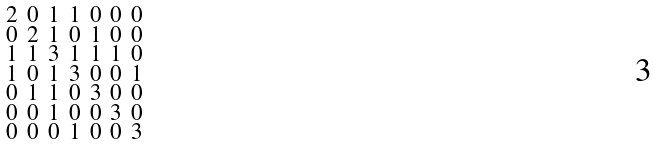Convert formula to latex. <formula><loc_0><loc_0><loc_500><loc_500>\begin{smallmatrix} 2 & 0 & 1 & 1 & 0 & 0 & 0 \\ 0 & 2 & 1 & 0 & 1 & 0 & 0 \\ 1 & 1 & 3 & 1 & 1 & 1 & 0 \\ 1 & 0 & 1 & 3 & 0 & 0 & 1 \\ 0 & 1 & 1 & 0 & 3 & 0 & 0 \\ 0 & 0 & 1 & 0 & 0 & 3 & 0 \\ 0 & 0 & 0 & 1 & 0 & 0 & 3 \end{smallmatrix}</formula> 